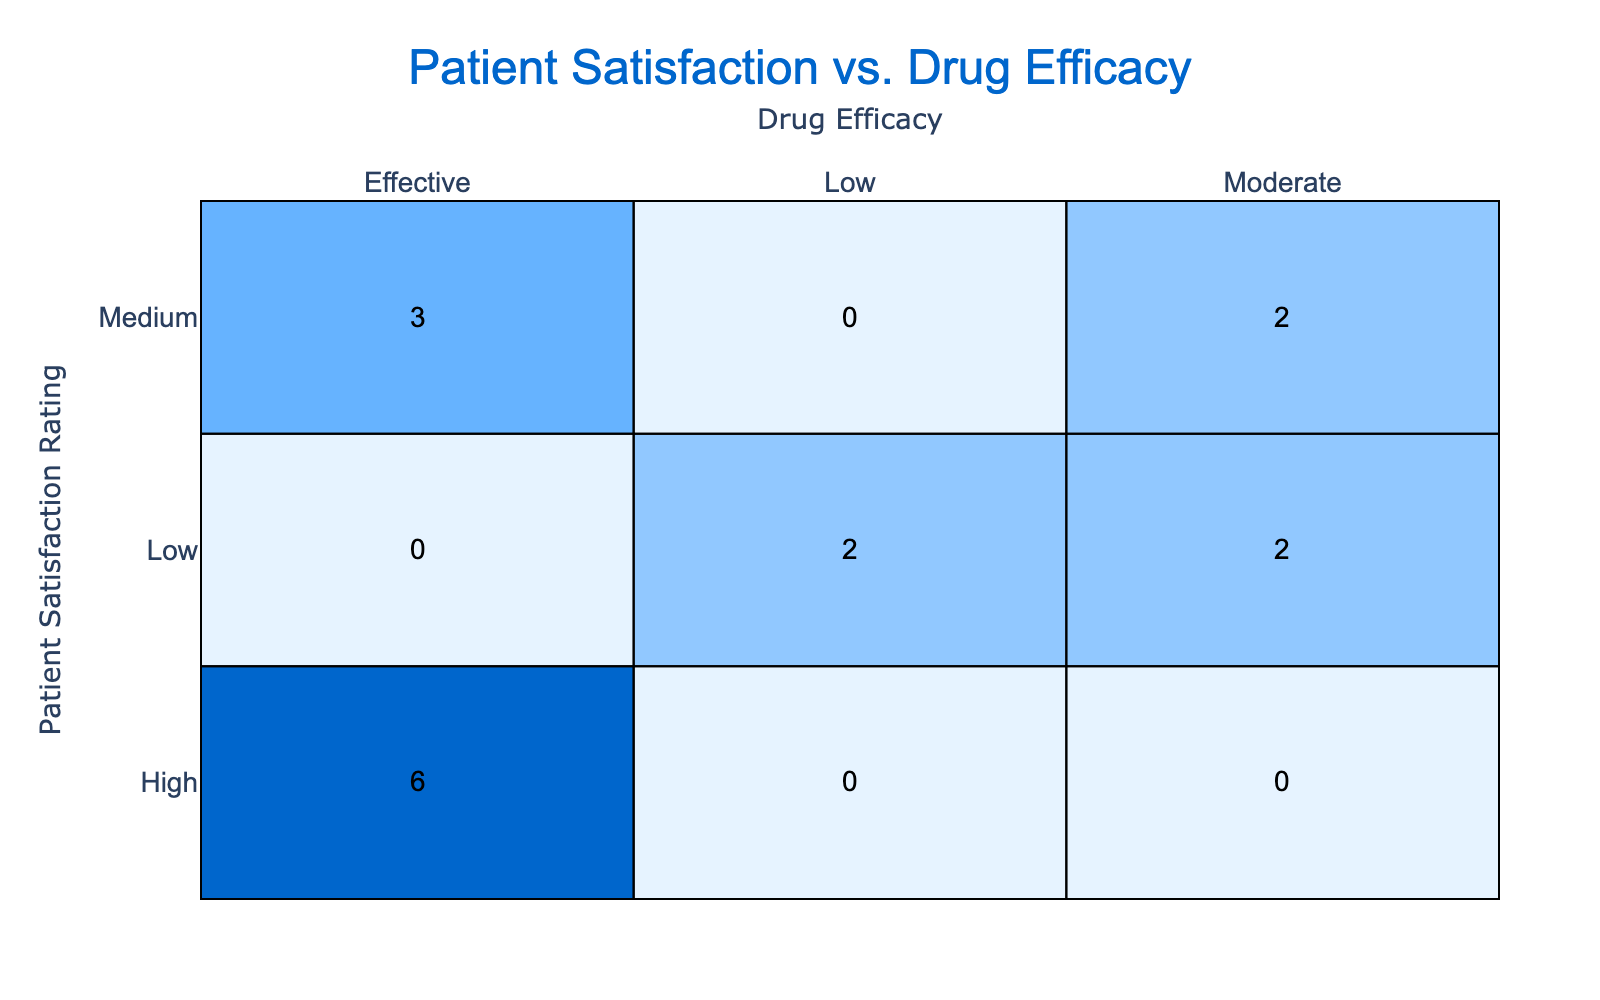What is the count of drugs rated as "High" for patient satisfaction that are also "Effective"? In the table, we look for the drugs listed under the "High" patient satisfaction rating and check their corresponding drug efficacy. The drugs OxyContin, Lyrica, Enbrel, Lipitor, Xeljanz, and Sovaldi all have a patient satisfaction rating of "High" and are rated as "Effective" for drug efficacy. Counting these gives us a total of 6 drugs.
Answer: 6 How many drugs have a "Low" patient satisfaction rating? We simply count the entries under "Low" in the patient satisfaction rating row. The drugs with a "Low" rating are Zoloft, Advil, Lexapro, and Zyban. Therefore, there are 4 drugs with a "Low" patient satisfaction rating.
Answer: 4 Is it true that no drugs with a "Medium" patient satisfaction rating are rated as "Low" for efficacy? To answer this, we check the "Medium" patient satisfaction rating in the table. The drugs listed here include Humira, Cymbalta, Pradaxa, and Truvada, and all of them are rated as "Effective" or "Moderate" for drug efficacy but none are rated as "Low". Thus, the statement is true.
Answer: True What is the total count of drugs that are rated "Moderate" for drug efficacy? We will identify how many drugs fall under the "Moderate" efficacy category, which includes Zoloft, Pradaxa, Lexapro, and Nexium. There are 4 drugs under this category, so the total count is 4.
Answer: 4 Which patient satisfaction rating has the highest number of drugs classified as "Effective"? We will analyze the occurrences of each patient satisfaction rating under the "Effective" column. The "High" rating includes OxyContin, Lyrica, Enbrel, Lipitor, Xeljanz, and Sovaldi, which totals 6 drugs. The "Medium" rating includes Truvada and Humira with only 2 drugs, while the "Low" has none for efficacy. Therefore, "High" satisfaction is the most, with 6 drugs.
Answer: High What percentage of drugs rated as "Effective" have a high patient satisfaction rating? To find this percentage, we first count how many drugs are rated as "Effective" which are OxyContin, Lyrica, Enbrel, Lipitor, Xeljanz, Humira, Cymbalta, Truvada, and Sovaldi, totaling 9 drugs. Out of these, 6 drugs have a "High" patient satisfaction rating. The percentage is calculated as (6/9) * 100 = 66.67%.
Answer: 66.67% How many "High" satisfaction drugs are classified as "Moderate"? We search the table for drugs that fall under the "High" rating category and check their efficacy. These include OxyContin, Lyrica, Enbrel, Lipitor, Xeljanz, and Sovaldi, all of which are "Effective". No "High" rated drugs are classified as "Moderate," thus the count is 0.
Answer: 0 Are there any drugs rated as both "High" for patient satisfaction and "Low" for efficacy? We check the entries for any drugs that combine these classifications. The drugs with "High" satisfaction include OxyContin, Lyrica, Enbrel, Lipitor, Xeljanz, and Sovaldi, and none of these are rated "Low" for efficacy. Thus, the answer is no.
Answer: No What is the ratio of drugs rated as "Low" to those rated as "Effective" for drug efficacy? We count the drugs rated as "Low": Advil, Zoloft, Lexapro, and Zyban, totaling 4. Next, we count the drugs rated as "Effective": OxyContin, Lyrica, Enbrel, Lipitor, Xeljanz, Humira, Cymbalta, Truvada, and Sovaldi, which total 9. The ratio of "Low" to "Effective" is therefore 4:9.
Answer: 4:9 